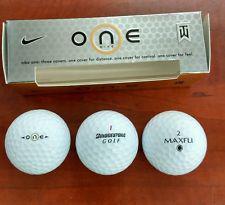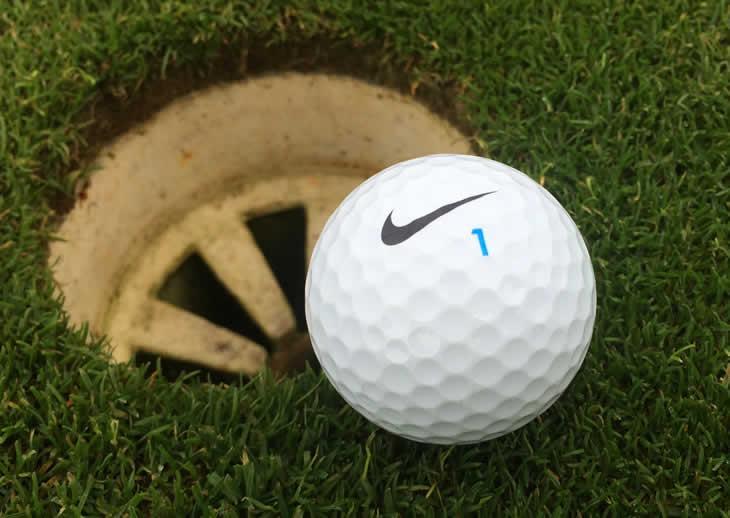The first image is the image on the left, the second image is the image on the right. Considering the images on both sides, is "There are three golf balls in the left image and one in the right." valid? Answer yes or no. Yes. The first image is the image on the left, the second image is the image on the right. Evaluate the accuracy of this statement regarding the images: "The left image features three white golf balls in a straight row under a silver box with gold trim.". Is it true? Answer yes or no. Yes. 